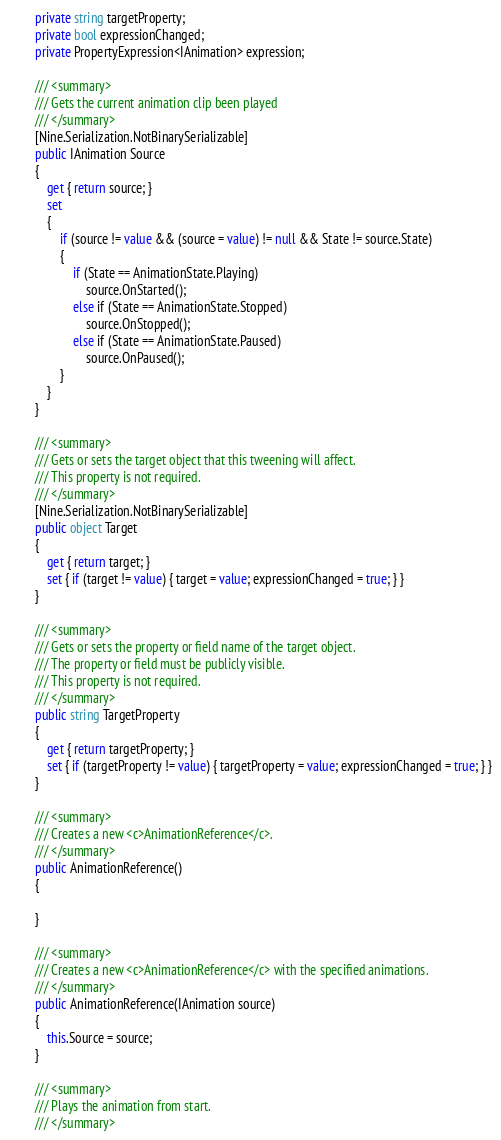Convert code to text. <code><loc_0><loc_0><loc_500><loc_500><_C#_>        private string targetProperty;
        private bool expressionChanged;
        private PropertyExpression<IAnimation> expression;

        /// <summary>
        /// Gets the current animation clip been played
        /// </summary>
        [Nine.Serialization.NotBinarySerializable]
        public IAnimation Source
        {
            get { return source; }
            set
            {
                if (source != value && (source = value) != null && State != source.State)
                {
                    if (State == AnimationState.Playing)
                        source.OnStarted();
                    else if (State == AnimationState.Stopped)
                        source.OnStopped();
                    else if (State == AnimationState.Paused)
                        source.OnPaused();
                }
            }
        }
        
        /// <summary>
        /// Gets or sets the target object that this tweening will affect.
        /// This property is not required.
        /// </summary>
        [Nine.Serialization.NotBinarySerializable]
        public object Target
        {
            get { return target; }
            set { if (target != value) { target = value; expressionChanged = true; } }
        }

        /// <summary>
        /// Gets or sets the property or field name of the target object.
        /// The property or field must be publicly visible.
        /// This property is not required.
        /// </summary>
        public string TargetProperty
        {
            get { return targetProperty; }
            set { if (targetProperty != value) { targetProperty = value; expressionChanged = true; } }
        }

        /// <summary>
        /// Creates a new <c>AnimationReference</c>.
        /// </summary>
        public AnimationReference()
        {

        }

        /// <summary>
        /// Creates a new <c>AnimationReference</c> with the specified animations.
        /// </summary>
        public AnimationReference(IAnimation source)
        {
            this.Source = source;
        }

        /// <summary>
        /// Plays the animation from start.
        /// </summary></code> 